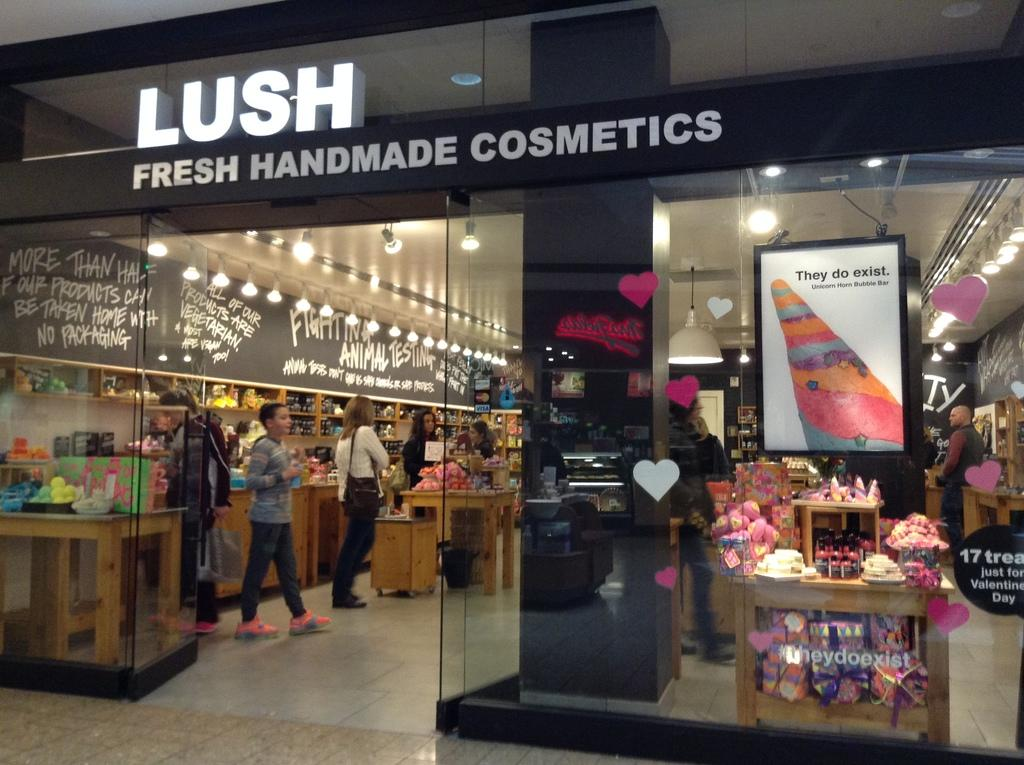<image>
Present a compact description of the photo's key features. entrance to lush fresh handmade cosmetics store and a few people inside looking around 